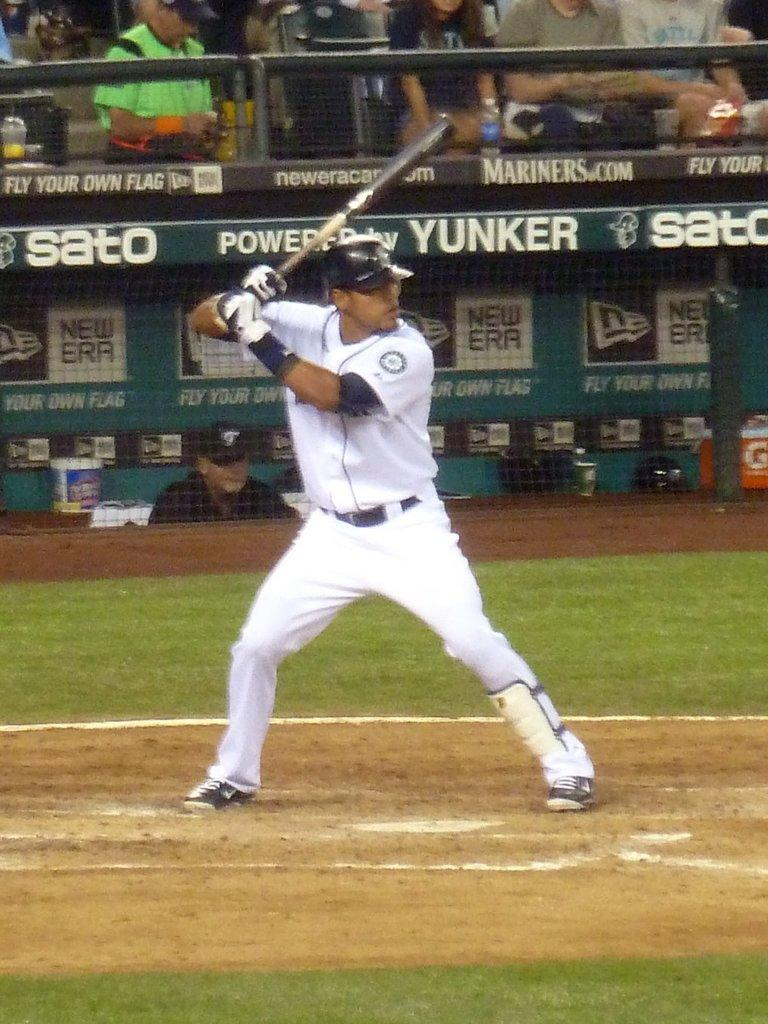<image>
Render a clear and concise summary of the photo. a dugout roof with the word yunker on the top edge 